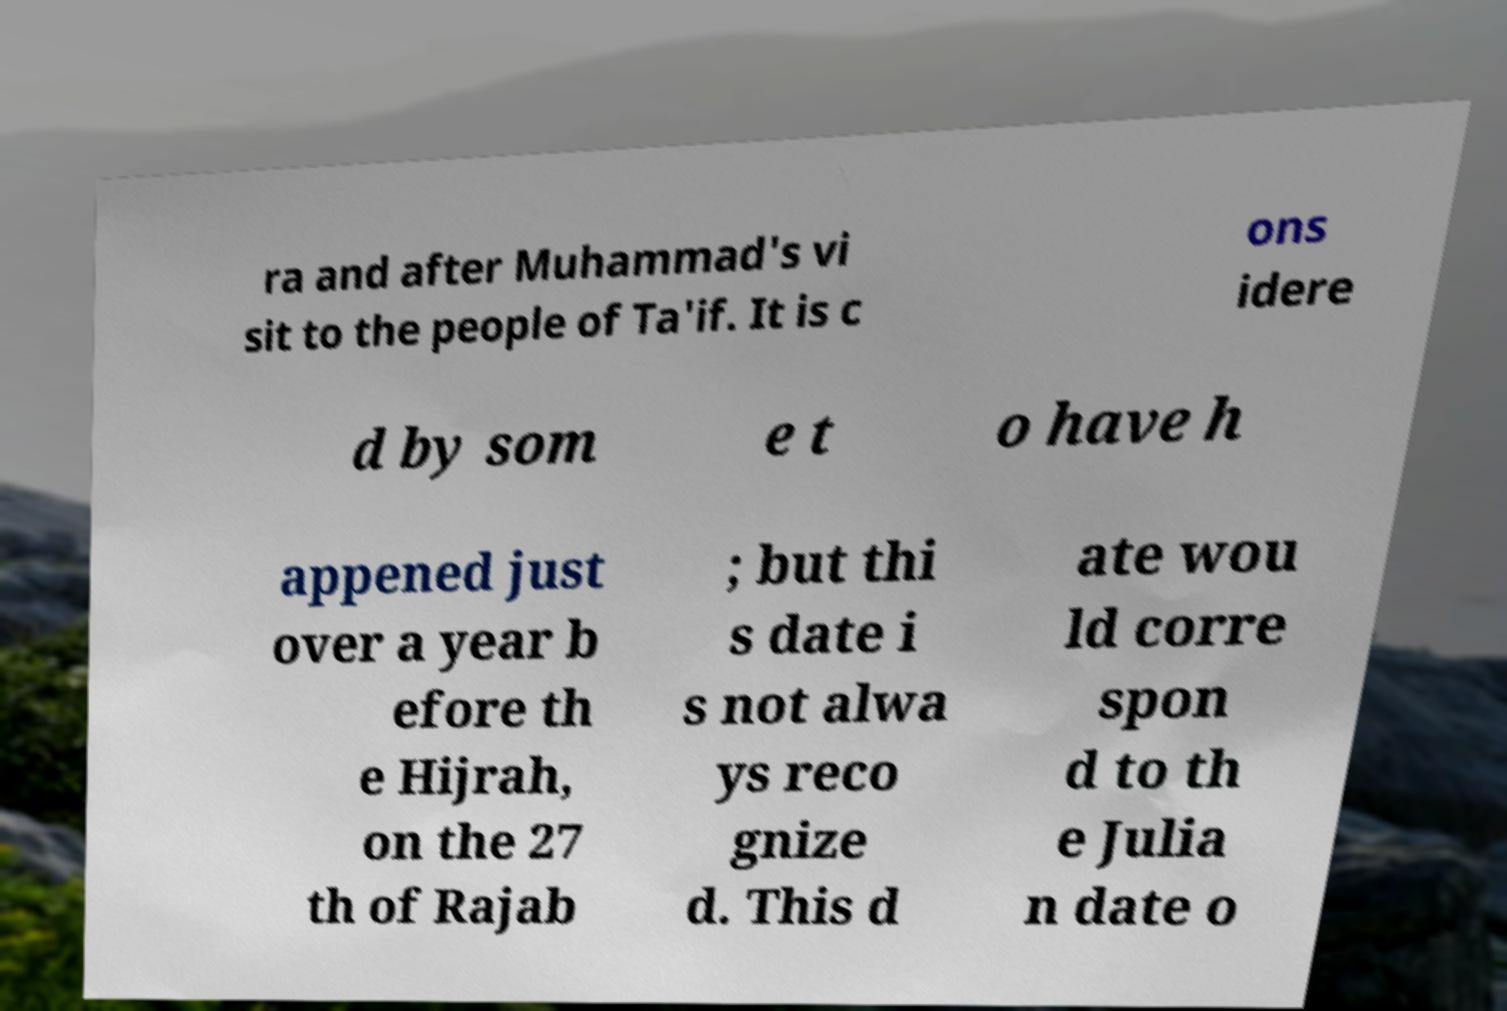Please read and relay the text visible in this image. What does it say? ra and after Muhammad's vi sit to the people of Ta'if. It is c ons idere d by som e t o have h appened just over a year b efore th e Hijrah, on the 27 th of Rajab ; but thi s date i s not alwa ys reco gnize d. This d ate wou ld corre spon d to th e Julia n date o 